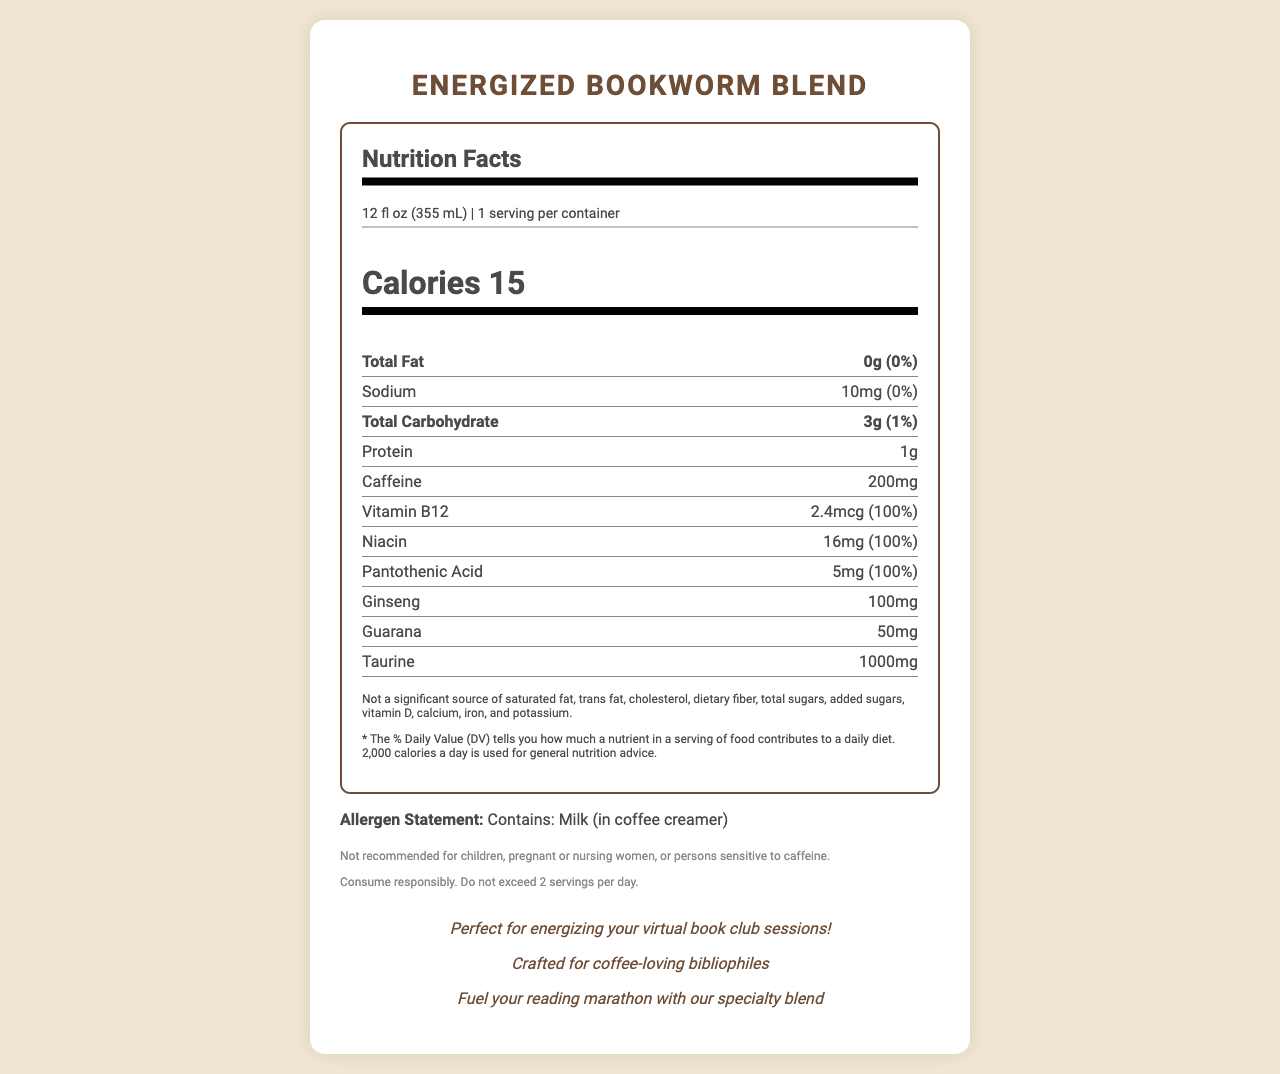what is the serving size of the Energized Bookworm Blend? The document explicitly states the serving size as 12 fl oz (355 mL).
Answer: 12 fl oz (355 mL) How many calories are in one serving of the Energized Bookworm Blend? The document lists the calorie content for one serving as 15 calories.
Answer: 15 What percentage of the daily value of Vitamin B12 does one serving provide? According to the document, one serving provides 100% of the daily value of Vitamin B12.
Answer: 100% How much caffeine does one serving contain? The document specifies that one serving contains 200mg of caffeine.
Answer: 200mg Are there any allergens listed in the Energized Bookworm Blend? The allergen statement in the document mentions that the product contains milk in the coffee creamer.
Answer: Yes, milk (in coffee creamer) What is the total amount of carbohydrates in one serving? The document indicates that one serving contains 3g of total carbohydrates.
Answer: 3g Which of the following nutrients is not present in significant amounts? A. Sodium B. Vitamin D C. Pantothenic Acid The additional info section states that Vitamin D is not a significant source in the product.
Answer: B. Vitamin D How much ginseng is in one serving of Energized Bookworm Blend? The document lists the amount of ginseng in one serving as 100mg.
Answer: 100mg What is the daily value percentage of sodium in one serving? The document states that the daily value percentage for sodium in one serving is 0%.
Answer: 0% What are the marketing claims of the Energized Bookworm Blend? A. Perfect for energizing virtual workouts B. Crafted for coffee-loving bibliophiles C. Helps with morning workouts The marketing claims listed include "Crafted for coffee-loving bibliophiles."
Answer: B. Crafted for coffee-loving bibliophiles Is the Energized Bookworm Blend recommended for pregnant women? The disclaimers section states that it is not recommended for pregnant or nursing women.
Answer: No Summarize the main idea of the document. The document primarily provides nutritional information, serving details, ingredient amounts, allergen statements, disclaimers, and marketing claims for the Energized Bookworm Blend.
Answer: The document is a detailed nutrition facts label for a specialty coffee blend called "Energized Bookworm Blend." This coffee contains energy-boosting supplements and provides significant daily values of several nutrients like Vitamin B12, Niacin, and Pantothenic Acid. It includes allergen information, disclaimers regarding caffeine sensitivity, and marketing claims targeting coffee-loving readers. What are the implications of consuming more than the recommended amount of Energized Bookworm Blend per day? The document advises against exceeding two servings per day but does not detail the specific health implications of doing so.
Answer: Not enough information 